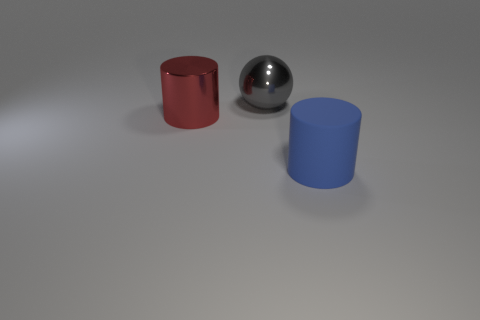Add 2 large red shiny things. How many objects exist? 5 Subtract all spheres. How many objects are left? 2 Add 3 red metal cylinders. How many red metal cylinders exist? 4 Subtract 0 cyan cylinders. How many objects are left? 3 Subtract all metallic cylinders. Subtract all purple objects. How many objects are left? 2 Add 1 large metal spheres. How many large metal spheres are left? 2 